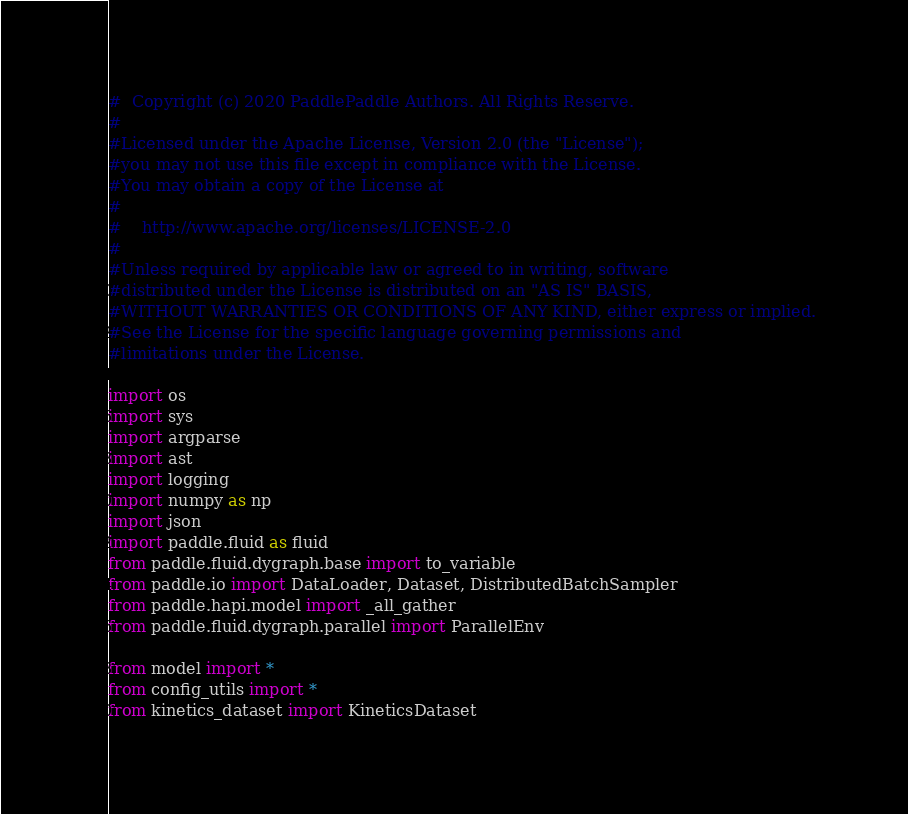Convert code to text. <code><loc_0><loc_0><loc_500><loc_500><_Python_>#  Copyright (c) 2020 PaddlePaddle Authors. All Rights Reserve.
#
#Licensed under the Apache License, Version 2.0 (the "License");
#you may not use this file except in compliance with the License.
#You may obtain a copy of the License at
#
#    http://www.apache.org/licenses/LICENSE-2.0
#
#Unless required by applicable law or agreed to in writing, software
#distributed under the License is distributed on an "AS IS" BASIS,
#WITHOUT WARRANTIES OR CONDITIONS OF ANY KIND, either express or implied.
#See the License for the specific language governing permissions and
#limitations under the License.

import os
import sys
import argparse
import ast
import logging
import numpy as np
import json
import paddle.fluid as fluid
from paddle.fluid.dygraph.base import to_variable
from paddle.io import DataLoader, Dataset, DistributedBatchSampler
from paddle.hapi.model import _all_gather
from paddle.fluid.dygraph.parallel import ParallelEnv

from model import *
from config_utils import *
from kinetics_dataset import KineticsDataset
</code> 